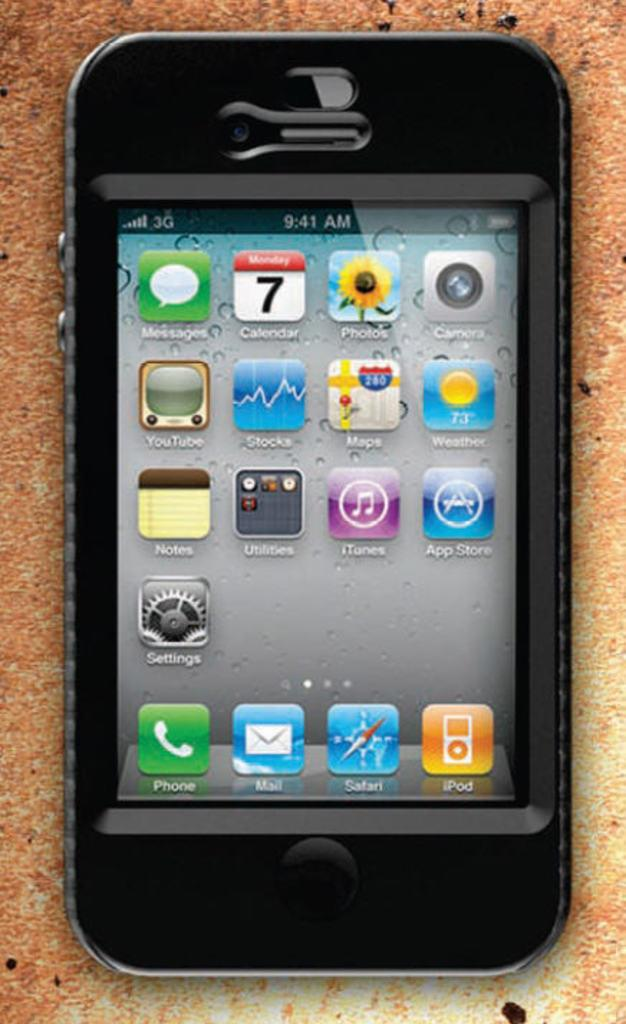<image>
Give a short and clear explanation of the subsequent image. A black iPhone has a bunch of apps installed including Messages, Calendar and Photos among others. 